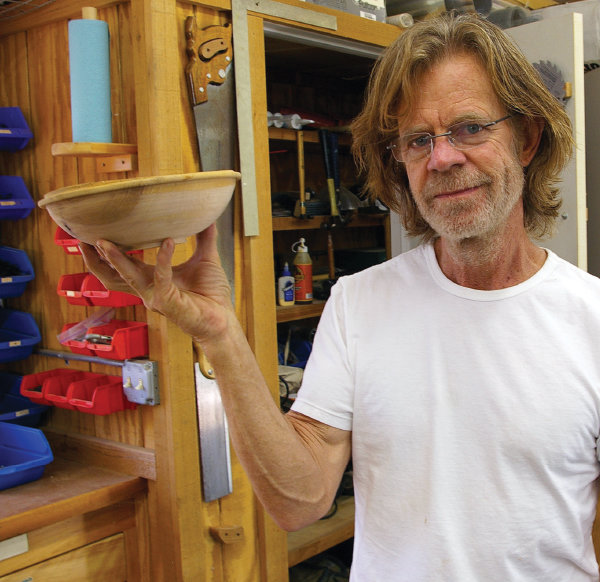Can you explain the significance or symbolism of woodworking in this context? Woodworking in this context seems to embody a personal passion or hobby that brings intrinsic satisfaction and joy. It symbolizes patience, skill, and the appreciation for craftsmanship. Engaging in such a hobby can provide a therapeutic effect, allowing the individual to express creativity while also achieving a sense of accomplishment from creating something tangible and useful. 